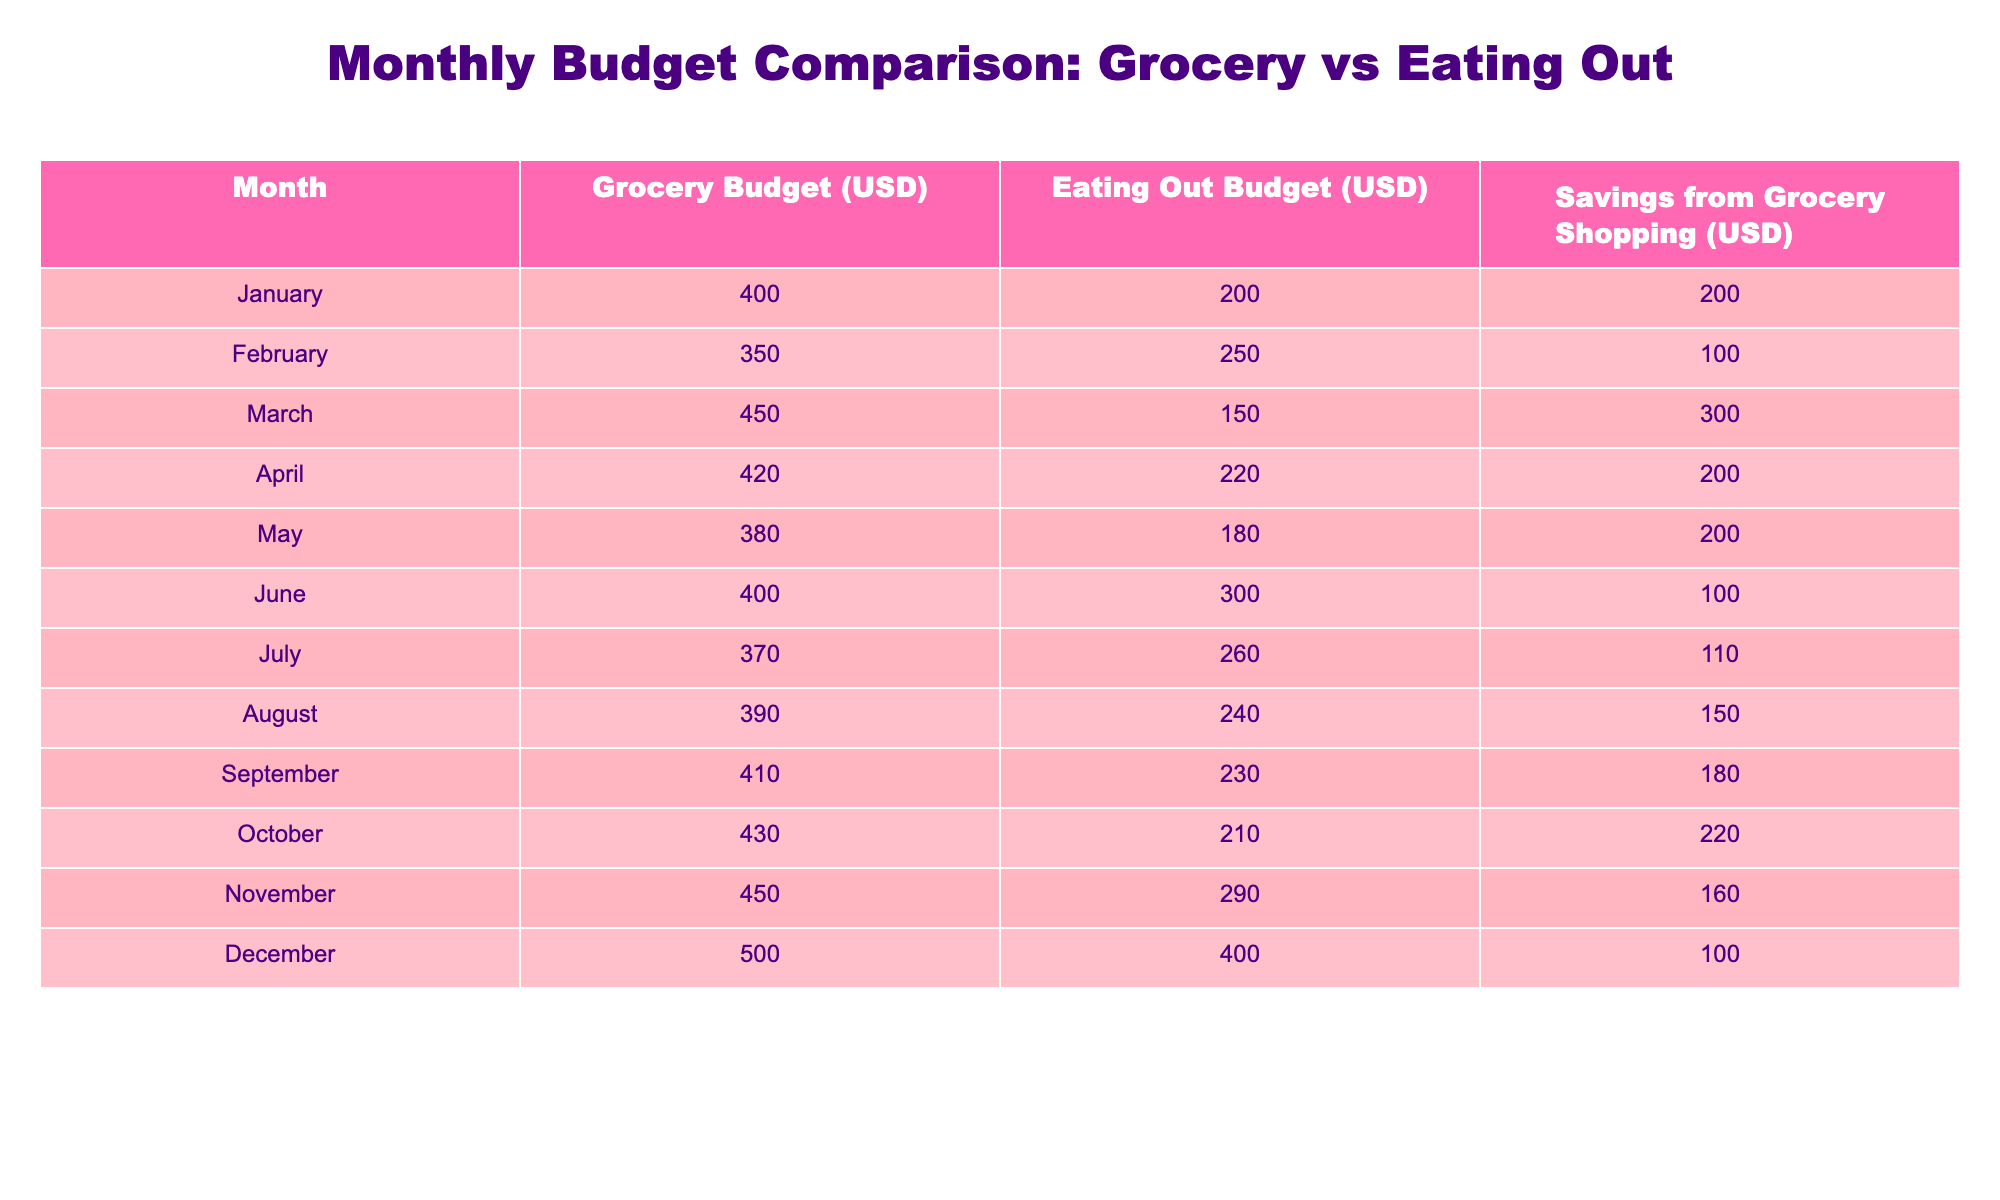What is the grocery budget for May? The table indicates that the grocery budget for May is directly listed in the "Grocery Budget (USD)" column under the "May" row. The value there is 380.
Answer: 380 What was the savings from grocery shopping in March? In the "March" row, the "Savings from Grocery Shopping (USD)" column shows that the savings amount is 300.
Answer: 300 In which month was the eating out budget the highest? By examining the "Eating Out Budget (USD)" column, the highest value is found in December, which is 400.
Answer: December What is the average grocery budget over the entire year? To find the average grocery budget, add all monthly grocery budgets (400 + 350 + 450 + 420 + 380 + 400 + 370 + 390 + 410 + 430 + 450 + 500) which equals to 4,680, and then divide by the number of months (12): 4680 / 12 = 390.
Answer: 390 Is the eating out budget ever lower than 200? Evaluating the "Eating Out Budget (USD)" column, comparing values shows that the only values below 200 occur in January (200) and February (250), but no values are ever listed under 200.
Answer: No Which month had the largest difference between grocery budget and eating out budget? The difference is calculated by subtracting the "Eating Out Budget (USD)" from the "Grocery Budget (USD)" for each month, and the largest difference is found in March: 450 (grocery) - 150 (eating out) = 300.
Answer: March How many months had savings greater than 200 from grocery shopping? By inspecting the "Savings from Grocery Shopping (USD)" column, the months with savings greater than 200 are March (300), and others are not above 200, so only one month qualifies.
Answer: 1 What is the total budget allocated for eating out from January to March? Adding the eating out budgets for January, February, and March gives: 200 (January) + 250 (February) + 150 (March) = 600.
Answer: 600 Was the grocery budget consistently over 400 in any month? Checking the "Grocery Budget (USD)" column, the values for January (400), February (350), and all later months indicate that January is not consistently over 400, and only documentation reveals it was above 400 only for a few months.
Answer: No 